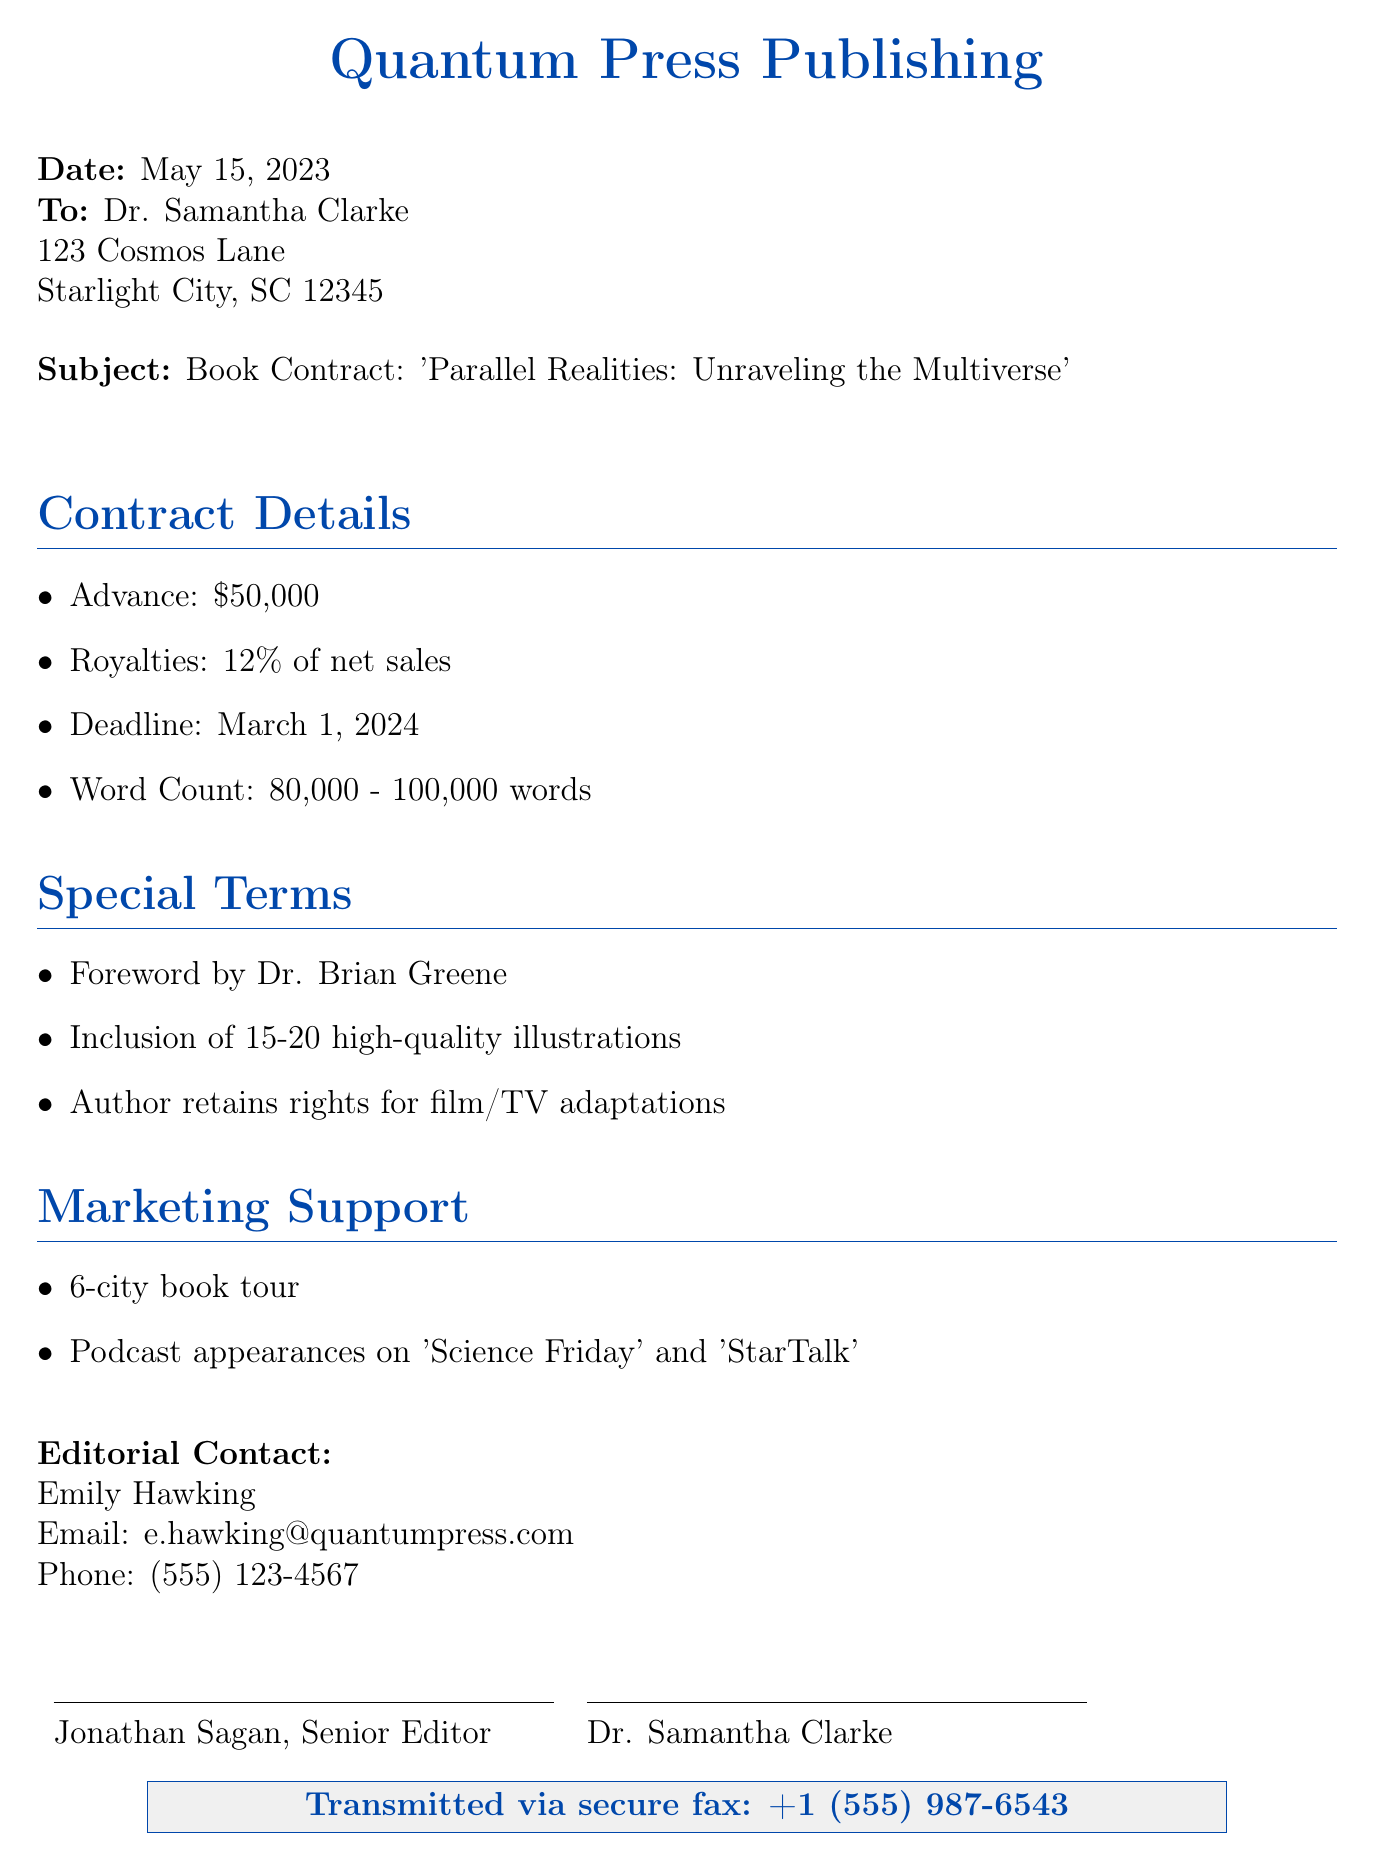What is the advance payment for the book? The advance payment is clearly stated in the contract details section, which mentions $50,000.
Answer: $50,000 What is the deadline for manuscript submission? The contract specifies March 1, 2024, as the deadline for the manuscript, indicating when the author needs to submit the work.
Answer: March 1, 2024 How many words should the book be? The document outlines the expected word count range for the book as 80,000 to 100,000 words.
Answer: 80,000 - 100,000 words Who is writing the foreword? The foreword is mentioned to be written by Dr. Brian Greene, indicating a notable figure in the scientific community will introduce the book.
Answer: Dr. Brian Greene What percentage of net sales does the author earn in royalties? The contract specifies a royalty rate of 12% of net sales, which indicates how much the author will earn from book sales.
Answer: 12% What type of marketing support is provided? The document highlights a 6-city book tour and podcast appearances as key marketing support strategies for the book's promotion.
Answer: 6-city book tour What rights does the author retain? The special terms section of the document indicates that the author retains rights for film/TV adaptations, which is crucial for potential media opportunities.
Answer: Film/TV adaptations What is the title of the book? The title is clearly stated at the beginning of the document as 'Parallel Realities: Unraveling the Multiverse,' which summarizes the content focus of the book.
Answer: Parallel Realities: Unraveling the Multiverse What is the name of the senior editor? The signature section at the bottom of the document provides the name Jonathan Sagan as the senior editor involved in the project.
Answer: Jonathan Sagan 